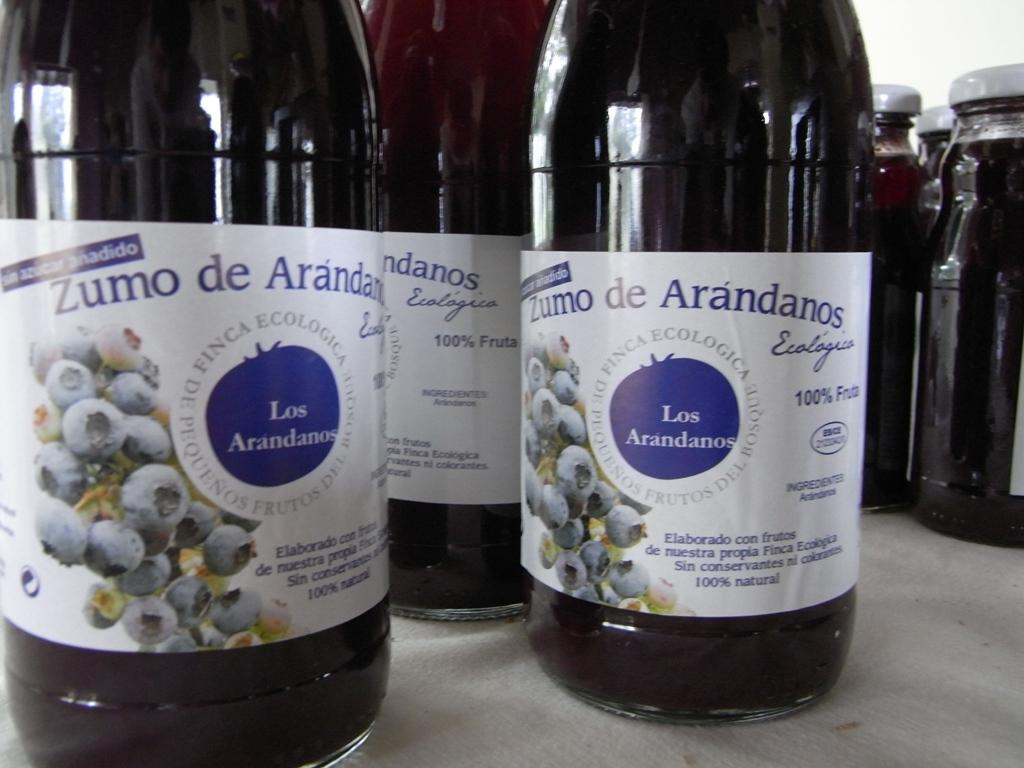<image>
Summarize the visual content of the image. Several bottles of Zumo De Arandanos 100% natural dark colored grape juice. 